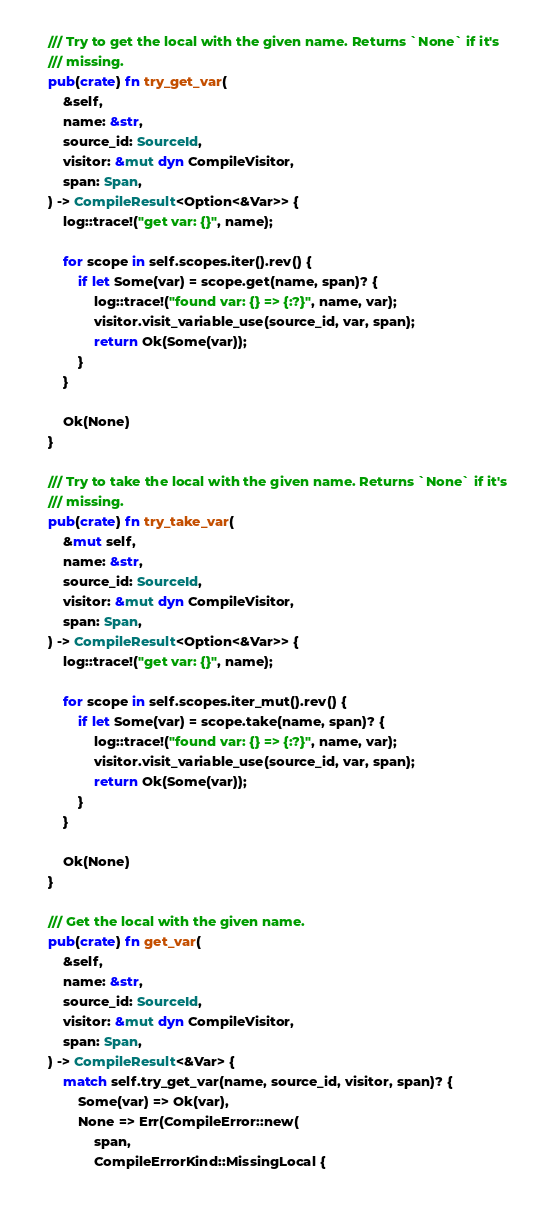Convert code to text. <code><loc_0><loc_0><loc_500><loc_500><_Rust_>    /// Try to get the local with the given name. Returns `None` if it's
    /// missing.
    pub(crate) fn try_get_var(
        &self,
        name: &str,
        source_id: SourceId,
        visitor: &mut dyn CompileVisitor,
        span: Span,
    ) -> CompileResult<Option<&Var>> {
        log::trace!("get var: {}", name);

        for scope in self.scopes.iter().rev() {
            if let Some(var) = scope.get(name, span)? {
                log::trace!("found var: {} => {:?}", name, var);
                visitor.visit_variable_use(source_id, var, span);
                return Ok(Some(var));
            }
        }

        Ok(None)
    }

    /// Try to take the local with the given name. Returns `None` if it's
    /// missing.
    pub(crate) fn try_take_var(
        &mut self,
        name: &str,
        source_id: SourceId,
        visitor: &mut dyn CompileVisitor,
        span: Span,
    ) -> CompileResult<Option<&Var>> {
        log::trace!("get var: {}", name);

        for scope in self.scopes.iter_mut().rev() {
            if let Some(var) = scope.take(name, span)? {
                log::trace!("found var: {} => {:?}", name, var);
                visitor.visit_variable_use(source_id, var, span);
                return Ok(Some(var));
            }
        }

        Ok(None)
    }

    /// Get the local with the given name.
    pub(crate) fn get_var(
        &self,
        name: &str,
        source_id: SourceId,
        visitor: &mut dyn CompileVisitor,
        span: Span,
    ) -> CompileResult<&Var> {
        match self.try_get_var(name, source_id, visitor, span)? {
            Some(var) => Ok(var),
            None => Err(CompileError::new(
                span,
                CompileErrorKind::MissingLocal {</code> 